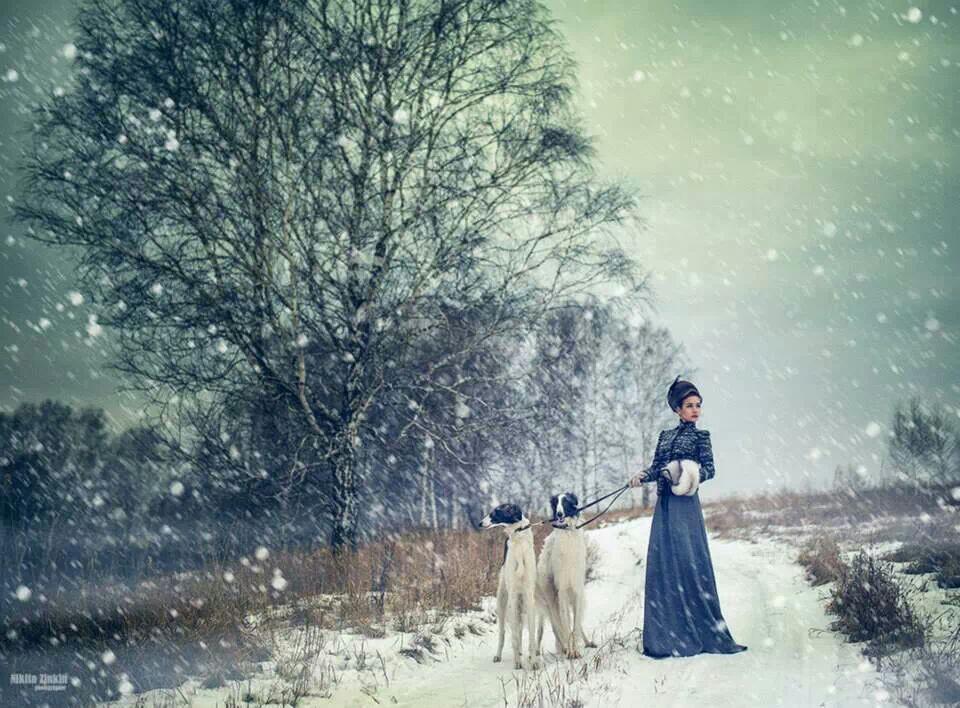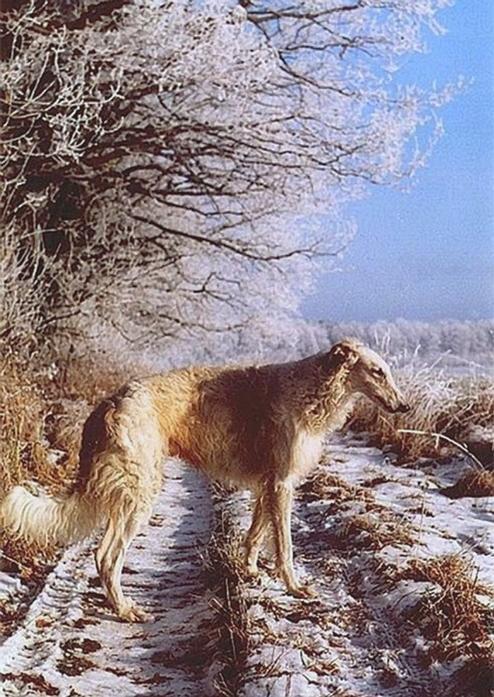The first image is the image on the left, the second image is the image on the right. Considering the images on both sides, is "One image is a wintry scene featuring a woman bundled up in a flowing garment with at least one hound on the left." valid? Answer yes or no. Yes. The first image is the image on the left, the second image is the image on the right. Given the left and right images, does the statement "There are three dogs and a woman" hold true? Answer yes or no. Yes. 